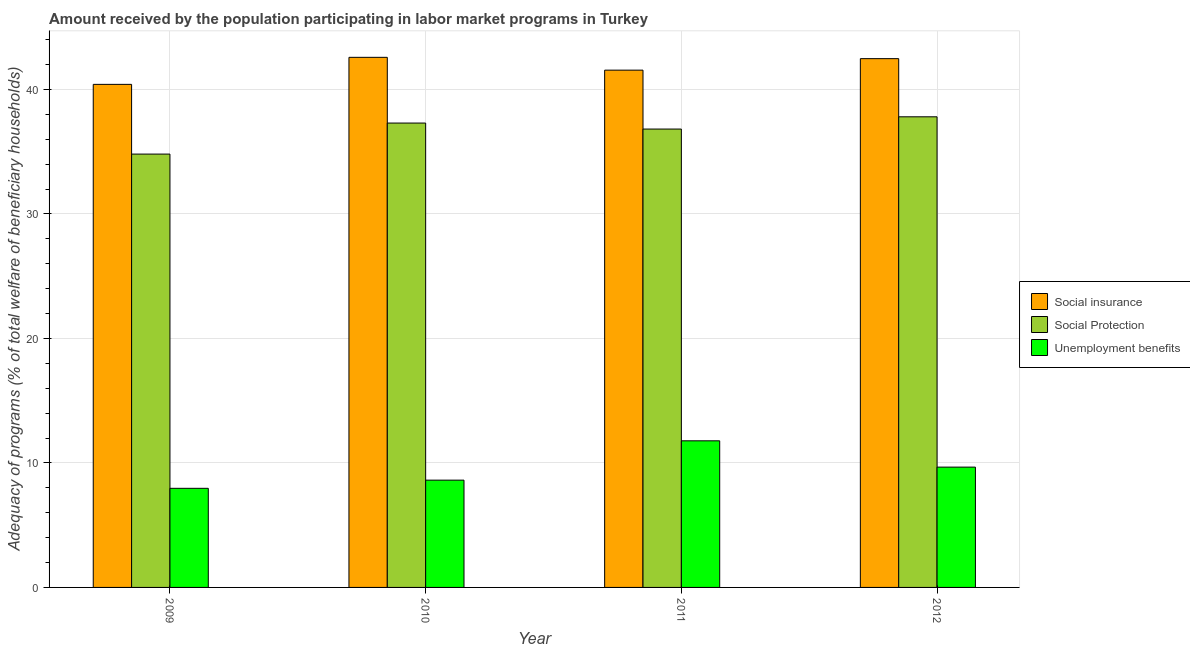How many different coloured bars are there?
Make the answer very short. 3. Are the number of bars per tick equal to the number of legend labels?
Provide a succinct answer. Yes. What is the label of the 1st group of bars from the left?
Provide a short and direct response. 2009. In how many cases, is the number of bars for a given year not equal to the number of legend labels?
Offer a very short reply. 0. What is the amount received by the population participating in social insurance programs in 2012?
Your answer should be compact. 42.47. Across all years, what is the maximum amount received by the population participating in social insurance programs?
Provide a succinct answer. 42.58. Across all years, what is the minimum amount received by the population participating in social insurance programs?
Offer a terse response. 40.41. In which year was the amount received by the population participating in unemployment benefits programs minimum?
Offer a very short reply. 2009. What is the total amount received by the population participating in social protection programs in the graph?
Offer a very short reply. 146.72. What is the difference between the amount received by the population participating in unemployment benefits programs in 2009 and that in 2011?
Ensure brevity in your answer.  -3.82. What is the difference between the amount received by the population participating in social protection programs in 2011 and the amount received by the population participating in social insurance programs in 2012?
Offer a very short reply. -0.98. What is the average amount received by the population participating in social insurance programs per year?
Make the answer very short. 41.75. In the year 2010, what is the difference between the amount received by the population participating in social protection programs and amount received by the population participating in social insurance programs?
Offer a terse response. 0. What is the ratio of the amount received by the population participating in social insurance programs in 2009 to that in 2011?
Your answer should be very brief. 0.97. What is the difference between the highest and the second highest amount received by the population participating in unemployment benefits programs?
Make the answer very short. 2.11. What is the difference between the highest and the lowest amount received by the population participating in social insurance programs?
Give a very brief answer. 2.17. In how many years, is the amount received by the population participating in unemployment benefits programs greater than the average amount received by the population participating in unemployment benefits programs taken over all years?
Provide a short and direct response. 2. What does the 1st bar from the left in 2012 represents?
Give a very brief answer. Social insurance. What does the 2nd bar from the right in 2012 represents?
Give a very brief answer. Social Protection. Is it the case that in every year, the sum of the amount received by the population participating in social insurance programs and amount received by the population participating in social protection programs is greater than the amount received by the population participating in unemployment benefits programs?
Your answer should be very brief. Yes. How many years are there in the graph?
Give a very brief answer. 4. What is the difference between two consecutive major ticks on the Y-axis?
Keep it short and to the point. 10. Are the values on the major ticks of Y-axis written in scientific E-notation?
Provide a short and direct response. No. Does the graph contain any zero values?
Provide a short and direct response. No. Does the graph contain grids?
Your answer should be very brief. Yes. What is the title of the graph?
Make the answer very short. Amount received by the population participating in labor market programs in Turkey. Does "Manufactures" appear as one of the legend labels in the graph?
Give a very brief answer. No. What is the label or title of the Y-axis?
Your response must be concise. Adequacy of programs (% of total welfare of beneficiary households). What is the Adequacy of programs (% of total welfare of beneficiary households) in Social insurance in 2009?
Make the answer very short. 40.41. What is the Adequacy of programs (% of total welfare of beneficiary households) in Social Protection in 2009?
Offer a very short reply. 34.81. What is the Adequacy of programs (% of total welfare of beneficiary households) of Unemployment benefits in 2009?
Your answer should be very brief. 7.96. What is the Adequacy of programs (% of total welfare of beneficiary households) in Social insurance in 2010?
Your response must be concise. 42.58. What is the Adequacy of programs (% of total welfare of beneficiary households) of Social Protection in 2010?
Give a very brief answer. 37.3. What is the Adequacy of programs (% of total welfare of beneficiary households) in Unemployment benefits in 2010?
Ensure brevity in your answer.  8.62. What is the Adequacy of programs (% of total welfare of beneficiary households) in Social insurance in 2011?
Your response must be concise. 41.55. What is the Adequacy of programs (% of total welfare of beneficiary households) in Social Protection in 2011?
Your answer should be very brief. 36.82. What is the Adequacy of programs (% of total welfare of beneficiary households) in Unemployment benefits in 2011?
Offer a very short reply. 11.78. What is the Adequacy of programs (% of total welfare of beneficiary households) of Social insurance in 2012?
Keep it short and to the point. 42.47. What is the Adequacy of programs (% of total welfare of beneficiary households) in Social Protection in 2012?
Your answer should be very brief. 37.8. What is the Adequacy of programs (% of total welfare of beneficiary households) in Unemployment benefits in 2012?
Provide a succinct answer. 9.66. Across all years, what is the maximum Adequacy of programs (% of total welfare of beneficiary households) of Social insurance?
Make the answer very short. 42.58. Across all years, what is the maximum Adequacy of programs (% of total welfare of beneficiary households) of Social Protection?
Provide a succinct answer. 37.8. Across all years, what is the maximum Adequacy of programs (% of total welfare of beneficiary households) in Unemployment benefits?
Your answer should be very brief. 11.78. Across all years, what is the minimum Adequacy of programs (% of total welfare of beneficiary households) of Social insurance?
Your answer should be compact. 40.41. Across all years, what is the minimum Adequacy of programs (% of total welfare of beneficiary households) of Social Protection?
Offer a terse response. 34.81. Across all years, what is the minimum Adequacy of programs (% of total welfare of beneficiary households) in Unemployment benefits?
Give a very brief answer. 7.96. What is the total Adequacy of programs (% of total welfare of beneficiary households) in Social insurance in the graph?
Your answer should be compact. 167. What is the total Adequacy of programs (% of total welfare of beneficiary households) in Social Protection in the graph?
Provide a short and direct response. 146.72. What is the total Adequacy of programs (% of total welfare of beneficiary households) in Unemployment benefits in the graph?
Make the answer very short. 38.02. What is the difference between the Adequacy of programs (% of total welfare of beneficiary households) in Social insurance in 2009 and that in 2010?
Offer a terse response. -2.17. What is the difference between the Adequacy of programs (% of total welfare of beneficiary households) of Social Protection in 2009 and that in 2010?
Provide a succinct answer. -2.49. What is the difference between the Adequacy of programs (% of total welfare of beneficiary households) of Unemployment benefits in 2009 and that in 2010?
Give a very brief answer. -0.66. What is the difference between the Adequacy of programs (% of total welfare of beneficiary households) of Social insurance in 2009 and that in 2011?
Your answer should be compact. -1.14. What is the difference between the Adequacy of programs (% of total welfare of beneficiary households) of Social Protection in 2009 and that in 2011?
Offer a very short reply. -2.01. What is the difference between the Adequacy of programs (% of total welfare of beneficiary households) in Unemployment benefits in 2009 and that in 2011?
Offer a very short reply. -3.82. What is the difference between the Adequacy of programs (% of total welfare of beneficiary households) in Social insurance in 2009 and that in 2012?
Offer a very short reply. -2.07. What is the difference between the Adequacy of programs (% of total welfare of beneficiary households) of Social Protection in 2009 and that in 2012?
Provide a succinct answer. -2.99. What is the difference between the Adequacy of programs (% of total welfare of beneficiary households) of Unemployment benefits in 2009 and that in 2012?
Your answer should be compact. -1.7. What is the difference between the Adequacy of programs (% of total welfare of beneficiary households) of Social insurance in 2010 and that in 2011?
Keep it short and to the point. 1.03. What is the difference between the Adequacy of programs (% of total welfare of beneficiary households) of Social Protection in 2010 and that in 2011?
Your response must be concise. 0.48. What is the difference between the Adequacy of programs (% of total welfare of beneficiary households) of Unemployment benefits in 2010 and that in 2011?
Provide a short and direct response. -3.16. What is the difference between the Adequacy of programs (% of total welfare of beneficiary households) in Social insurance in 2010 and that in 2012?
Offer a terse response. 0.11. What is the difference between the Adequacy of programs (% of total welfare of beneficiary households) of Social Protection in 2010 and that in 2012?
Offer a terse response. -0.5. What is the difference between the Adequacy of programs (% of total welfare of beneficiary households) in Unemployment benefits in 2010 and that in 2012?
Provide a succinct answer. -1.05. What is the difference between the Adequacy of programs (% of total welfare of beneficiary households) in Social insurance in 2011 and that in 2012?
Provide a short and direct response. -0.92. What is the difference between the Adequacy of programs (% of total welfare of beneficiary households) in Social Protection in 2011 and that in 2012?
Your response must be concise. -0.98. What is the difference between the Adequacy of programs (% of total welfare of beneficiary households) in Unemployment benefits in 2011 and that in 2012?
Offer a terse response. 2.11. What is the difference between the Adequacy of programs (% of total welfare of beneficiary households) in Social insurance in 2009 and the Adequacy of programs (% of total welfare of beneficiary households) in Social Protection in 2010?
Provide a short and direct response. 3.11. What is the difference between the Adequacy of programs (% of total welfare of beneficiary households) of Social insurance in 2009 and the Adequacy of programs (% of total welfare of beneficiary households) of Unemployment benefits in 2010?
Your response must be concise. 31.79. What is the difference between the Adequacy of programs (% of total welfare of beneficiary households) of Social Protection in 2009 and the Adequacy of programs (% of total welfare of beneficiary households) of Unemployment benefits in 2010?
Ensure brevity in your answer.  26.19. What is the difference between the Adequacy of programs (% of total welfare of beneficiary households) of Social insurance in 2009 and the Adequacy of programs (% of total welfare of beneficiary households) of Social Protection in 2011?
Your response must be concise. 3.59. What is the difference between the Adequacy of programs (% of total welfare of beneficiary households) of Social insurance in 2009 and the Adequacy of programs (% of total welfare of beneficiary households) of Unemployment benefits in 2011?
Ensure brevity in your answer.  28.63. What is the difference between the Adequacy of programs (% of total welfare of beneficiary households) of Social Protection in 2009 and the Adequacy of programs (% of total welfare of beneficiary households) of Unemployment benefits in 2011?
Offer a very short reply. 23.03. What is the difference between the Adequacy of programs (% of total welfare of beneficiary households) of Social insurance in 2009 and the Adequacy of programs (% of total welfare of beneficiary households) of Social Protection in 2012?
Ensure brevity in your answer.  2.61. What is the difference between the Adequacy of programs (% of total welfare of beneficiary households) in Social insurance in 2009 and the Adequacy of programs (% of total welfare of beneficiary households) in Unemployment benefits in 2012?
Make the answer very short. 30.74. What is the difference between the Adequacy of programs (% of total welfare of beneficiary households) in Social Protection in 2009 and the Adequacy of programs (% of total welfare of beneficiary households) in Unemployment benefits in 2012?
Give a very brief answer. 25.14. What is the difference between the Adequacy of programs (% of total welfare of beneficiary households) in Social insurance in 2010 and the Adequacy of programs (% of total welfare of beneficiary households) in Social Protection in 2011?
Your answer should be very brief. 5.76. What is the difference between the Adequacy of programs (% of total welfare of beneficiary households) of Social insurance in 2010 and the Adequacy of programs (% of total welfare of beneficiary households) of Unemployment benefits in 2011?
Your response must be concise. 30.8. What is the difference between the Adequacy of programs (% of total welfare of beneficiary households) in Social Protection in 2010 and the Adequacy of programs (% of total welfare of beneficiary households) in Unemployment benefits in 2011?
Provide a short and direct response. 25.52. What is the difference between the Adequacy of programs (% of total welfare of beneficiary households) of Social insurance in 2010 and the Adequacy of programs (% of total welfare of beneficiary households) of Social Protection in 2012?
Your response must be concise. 4.78. What is the difference between the Adequacy of programs (% of total welfare of beneficiary households) in Social insurance in 2010 and the Adequacy of programs (% of total welfare of beneficiary households) in Unemployment benefits in 2012?
Provide a succinct answer. 32.91. What is the difference between the Adequacy of programs (% of total welfare of beneficiary households) in Social Protection in 2010 and the Adequacy of programs (% of total welfare of beneficiary households) in Unemployment benefits in 2012?
Provide a short and direct response. 27.63. What is the difference between the Adequacy of programs (% of total welfare of beneficiary households) in Social insurance in 2011 and the Adequacy of programs (% of total welfare of beneficiary households) in Social Protection in 2012?
Give a very brief answer. 3.75. What is the difference between the Adequacy of programs (% of total welfare of beneficiary households) in Social insurance in 2011 and the Adequacy of programs (% of total welfare of beneficiary households) in Unemployment benefits in 2012?
Make the answer very short. 31.88. What is the difference between the Adequacy of programs (% of total welfare of beneficiary households) in Social Protection in 2011 and the Adequacy of programs (% of total welfare of beneficiary households) in Unemployment benefits in 2012?
Give a very brief answer. 27.15. What is the average Adequacy of programs (% of total welfare of beneficiary households) in Social insurance per year?
Your answer should be compact. 41.75. What is the average Adequacy of programs (% of total welfare of beneficiary households) in Social Protection per year?
Ensure brevity in your answer.  36.68. What is the average Adequacy of programs (% of total welfare of beneficiary households) of Unemployment benefits per year?
Your answer should be very brief. 9.5. In the year 2009, what is the difference between the Adequacy of programs (% of total welfare of beneficiary households) in Social insurance and Adequacy of programs (% of total welfare of beneficiary households) in Social Protection?
Offer a very short reply. 5.6. In the year 2009, what is the difference between the Adequacy of programs (% of total welfare of beneficiary households) of Social insurance and Adequacy of programs (% of total welfare of beneficiary households) of Unemployment benefits?
Make the answer very short. 32.45. In the year 2009, what is the difference between the Adequacy of programs (% of total welfare of beneficiary households) in Social Protection and Adequacy of programs (% of total welfare of beneficiary households) in Unemployment benefits?
Ensure brevity in your answer.  26.85. In the year 2010, what is the difference between the Adequacy of programs (% of total welfare of beneficiary households) of Social insurance and Adequacy of programs (% of total welfare of beneficiary households) of Social Protection?
Make the answer very short. 5.28. In the year 2010, what is the difference between the Adequacy of programs (% of total welfare of beneficiary households) in Social insurance and Adequacy of programs (% of total welfare of beneficiary households) in Unemployment benefits?
Your answer should be compact. 33.96. In the year 2010, what is the difference between the Adequacy of programs (% of total welfare of beneficiary households) of Social Protection and Adequacy of programs (% of total welfare of beneficiary households) of Unemployment benefits?
Provide a short and direct response. 28.68. In the year 2011, what is the difference between the Adequacy of programs (% of total welfare of beneficiary households) of Social insurance and Adequacy of programs (% of total welfare of beneficiary households) of Social Protection?
Offer a very short reply. 4.73. In the year 2011, what is the difference between the Adequacy of programs (% of total welfare of beneficiary households) of Social insurance and Adequacy of programs (% of total welfare of beneficiary households) of Unemployment benefits?
Provide a short and direct response. 29.77. In the year 2011, what is the difference between the Adequacy of programs (% of total welfare of beneficiary households) of Social Protection and Adequacy of programs (% of total welfare of beneficiary households) of Unemployment benefits?
Your response must be concise. 25.04. In the year 2012, what is the difference between the Adequacy of programs (% of total welfare of beneficiary households) of Social insurance and Adequacy of programs (% of total welfare of beneficiary households) of Social Protection?
Your answer should be compact. 4.67. In the year 2012, what is the difference between the Adequacy of programs (% of total welfare of beneficiary households) in Social insurance and Adequacy of programs (% of total welfare of beneficiary households) in Unemployment benefits?
Offer a terse response. 32.81. In the year 2012, what is the difference between the Adequacy of programs (% of total welfare of beneficiary households) in Social Protection and Adequacy of programs (% of total welfare of beneficiary households) in Unemployment benefits?
Your answer should be compact. 28.14. What is the ratio of the Adequacy of programs (% of total welfare of beneficiary households) of Social insurance in 2009 to that in 2010?
Give a very brief answer. 0.95. What is the ratio of the Adequacy of programs (% of total welfare of beneficiary households) of Social Protection in 2009 to that in 2010?
Give a very brief answer. 0.93. What is the ratio of the Adequacy of programs (% of total welfare of beneficiary households) of Unemployment benefits in 2009 to that in 2010?
Give a very brief answer. 0.92. What is the ratio of the Adequacy of programs (% of total welfare of beneficiary households) of Social insurance in 2009 to that in 2011?
Provide a short and direct response. 0.97. What is the ratio of the Adequacy of programs (% of total welfare of beneficiary households) of Social Protection in 2009 to that in 2011?
Make the answer very short. 0.95. What is the ratio of the Adequacy of programs (% of total welfare of beneficiary households) in Unemployment benefits in 2009 to that in 2011?
Ensure brevity in your answer.  0.68. What is the ratio of the Adequacy of programs (% of total welfare of beneficiary households) of Social insurance in 2009 to that in 2012?
Ensure brevity in your answer.  0.95. What is the ratio of the Adequacy of programs (% of total welfare of beneficiary households) in Social Protection in 2009 to that in 2012?
Ensure brevity in your answer.  0.92. What is the ratio of the Adequacy of programs (% of total welfare of beneficiary households) of Unemployment benefits in 2009 to that in 2012?
Your answer should be compact. 0.82. What is the ratio of the Adequacy of programs (% of total welfare of beneficiary households) in Social insurance in 2010 to that in 2011?
Offer a terse response. 1.02. What is the ratio of the Adequacy of programs (% of total welfare of beneficiary households) of Social Protection in 2010 to that in 2011?
Your answer should be very brief. 1.01. What is the ratio of the Adequacy of programs (% of total welfare of beneficiary households) of Unemployment benefits in 2010 to that in 2011?
Provide a short and direct response. 0.73. What is the ratio of the Adequacy of programs (% of total welfare of beneficiary households) in Social insurance in 2010 to that in 2012?
Keep it short and to the point. 1. What is the ratio of the Adequacy of programs (% of total welfare of beneficiary households) in Social Protection in 2010 to that in 2012?
Offer a very short reply. 0.99. What is the ratio of the Adequacy of programs (% of total welfare of beneficiary households) in Unemployment benefits in 2010 to that in 2012?
Make the answer very short. 0.89. What is the ratio of the Adequacy of programs (% of total welfare of beneficiary households) in Social insurance in 2011 to that in 2012?
Your response must be concise. 0.98. What is the ratio of the Adequacy of programs (% of total welfare of beneficiary households) of Social Protection in 2011 to that in 2012?
Your answer should be compact. 0.97. What is the ratio of the Adequacy of programs (% of total welfare of beneficiary households) of Unemployment benefits in 2011 to that in 2012?
Give a very brief answer. 1.22. What is the difference between the highest and the second highest Adequacy of programs (% of total welfare of beneficiary households) of Social insurance?
Offer a very short reply. 0.11. What is the difference between the highest and the second highest Adequacy of programs (% of total welfare of beneficiary households) of Social Protection?
Provide a succinct answer. 0.5. What is the difference between the highest and the second highest Adequacy of programs (% of total welfare of beneficiary households) of Unemployment benefits?
Your answer should be compact. 2.11. What is the difference between the highest and the lowest Adequacy of programs (% of total welfare of beneficiary households) in Social insurance?
Provide a short and direct response. 2.17. What is the difference between the highest and the lowest Adequacy of programs (% of total welfare of beneficiary households) in Social Protection?
Offer a terse response. 2.99. What is the difference between the highest and the lowest Adequacy of programs (% of total welfare of beneficiary households) in Unemployment benefits?
Your answer should be very brief. 3.82. 